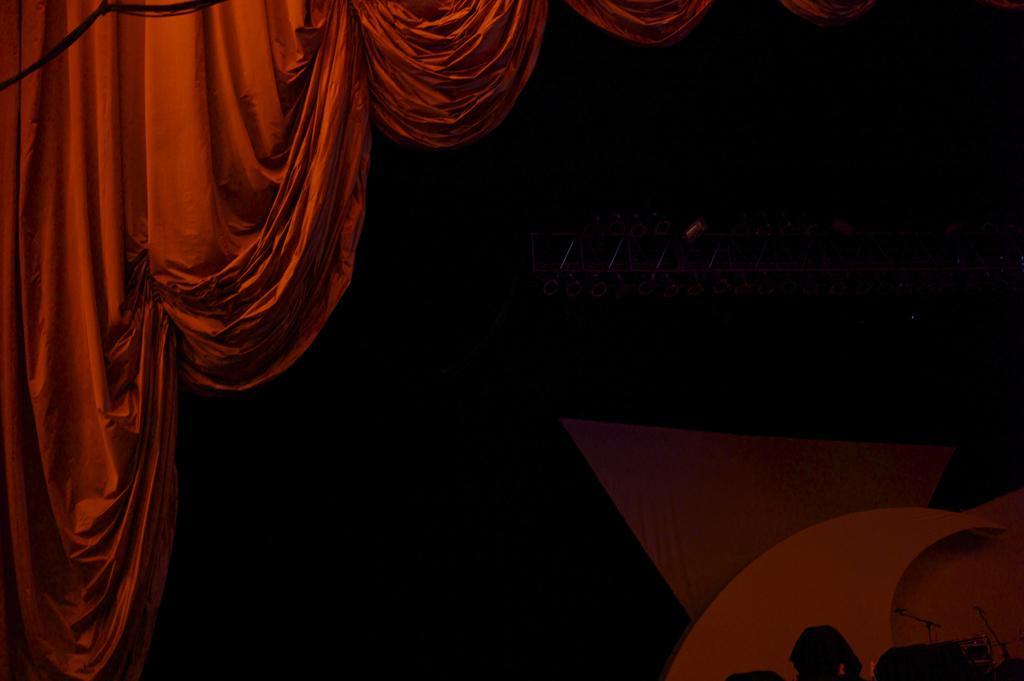How would you summarize this image in a sentence or two? In this image there is a red curtain. The background is dark. 